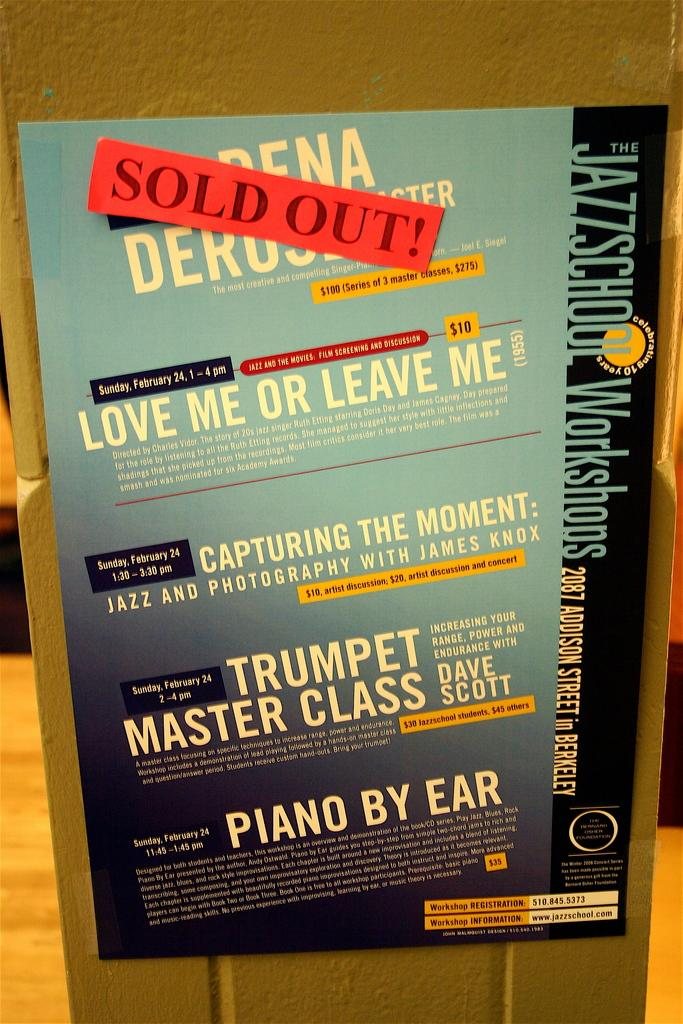<image>
Relay a brief, clear account of the picture shown. Sold out show of a jazz school work shop 